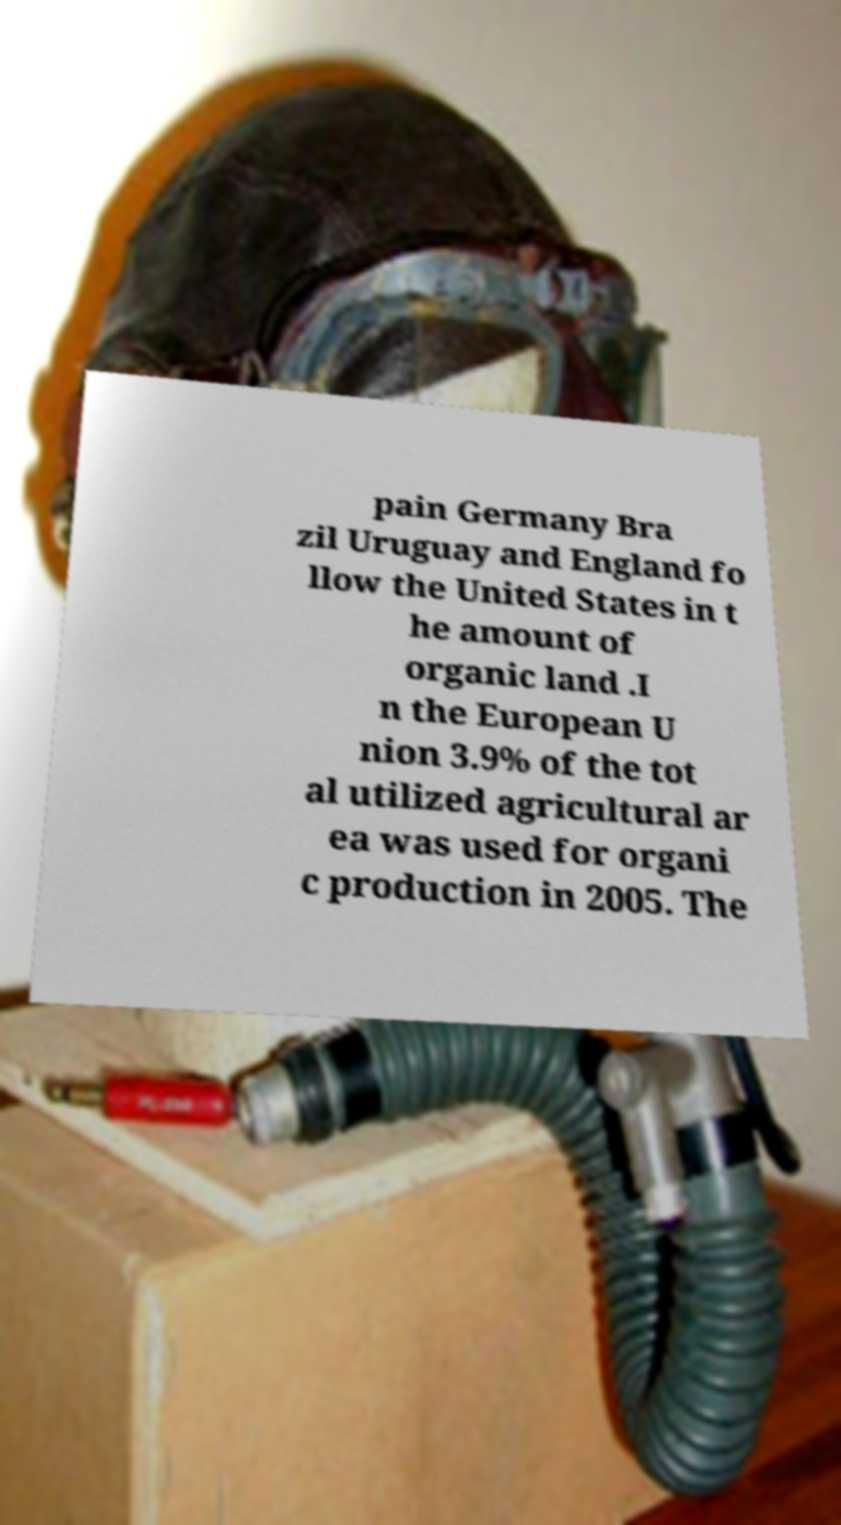Can you accurately transcribe the text from the provided image for me? pain Germany Bra zil Uruguay and England fo llow the United States in t he amount of organic land .I n the European U nion 3.9% of the tot al utilized agricultural ar ea was used for organi c production in 2005. The 